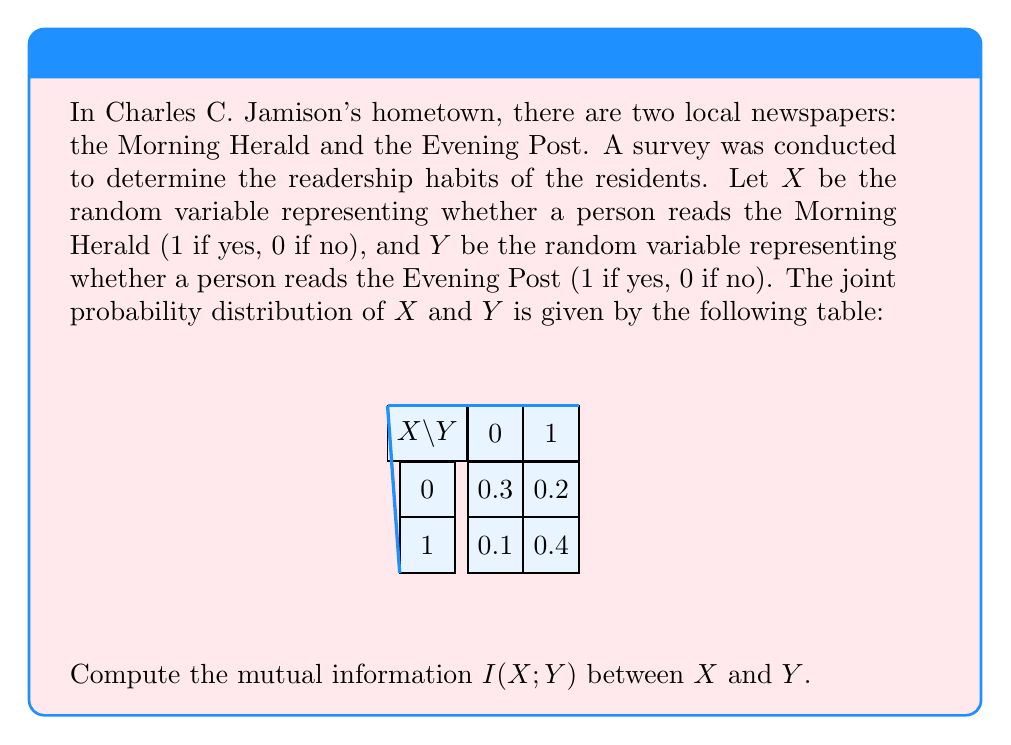Give your solution to this math problem. To compute the mutual information I(X;Y), we'll follow these steps:

1) The mutual information is defined as:

   $$I(X;Y) = \sum_{x,y} p(x,y) \log_2 \frac{p(x,y)}{p(x)p(y)}$$

2) First, let's calculate the marginal probabilities:
   
   $p(X=0) = 0.3 + 0.2 = 0.5$
   $p(X=1) = 0.1 + 0.4 = 0.5$
   $p(Y=0) = 0.3 + 0.1 = 0.4$
   $p(Y=1) = 0.2 + 0.4 = 0.6$

3) Now, we can calculate each term of the sum:

   For $x=0, y=0$: $0.3 \log_2 \frac{0.3}{0.5 \cdot 0.4} = 0.3 \log_2 1.5 \approx 0.1368$
   
   For $x=0, y=1$: $0.2 \log_2 \frac{0.2}{0.5 \cdot 0.6} \approx -0.0630$
   
   For $x=1, y=0$: $0.1 \log_2 \frac{0.1}{0.5 \cdot 0.4} \approx -0.1368$
   
   For $x=1, y=1$: $0.4 \log_2 \frac{0.4}{0.5 \cdot 0.6} \approx 0.1926$

4) Sum all these terms:

   $I(X;Y) = 0.1368 - 0.0630 - 0.1368 + 0.1926 = 0.1296$ bits
Answer: 0.1296 bits 